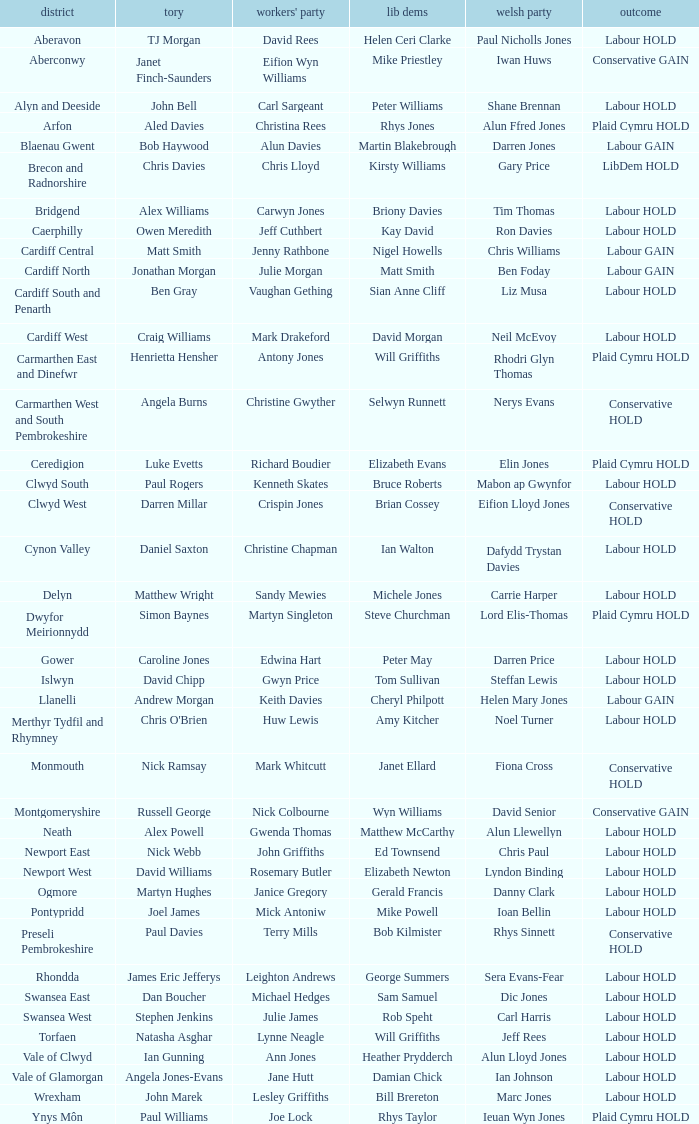What constituency does the Conservative Darren Millar belong to? Clwyd West. 